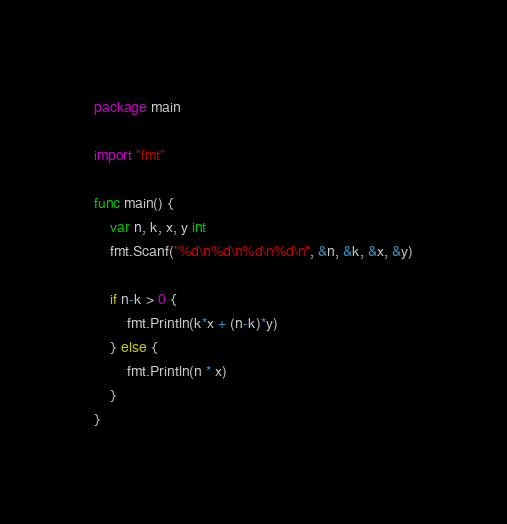<code> <loc_0><loc_0><loc_500><loc_500><_Go_>package main

import "fmt"

func main() {
	var n, k, x, y int
	fmt.Scanf("%d\n%d\n%d\n%d\n", &n, &k, &x, &y)

	if n-k > 0 {
		fmt.Println(k*x + (n-k)*y)
	} else {
		fmt.Println(n * x)
	}
}
</code> 